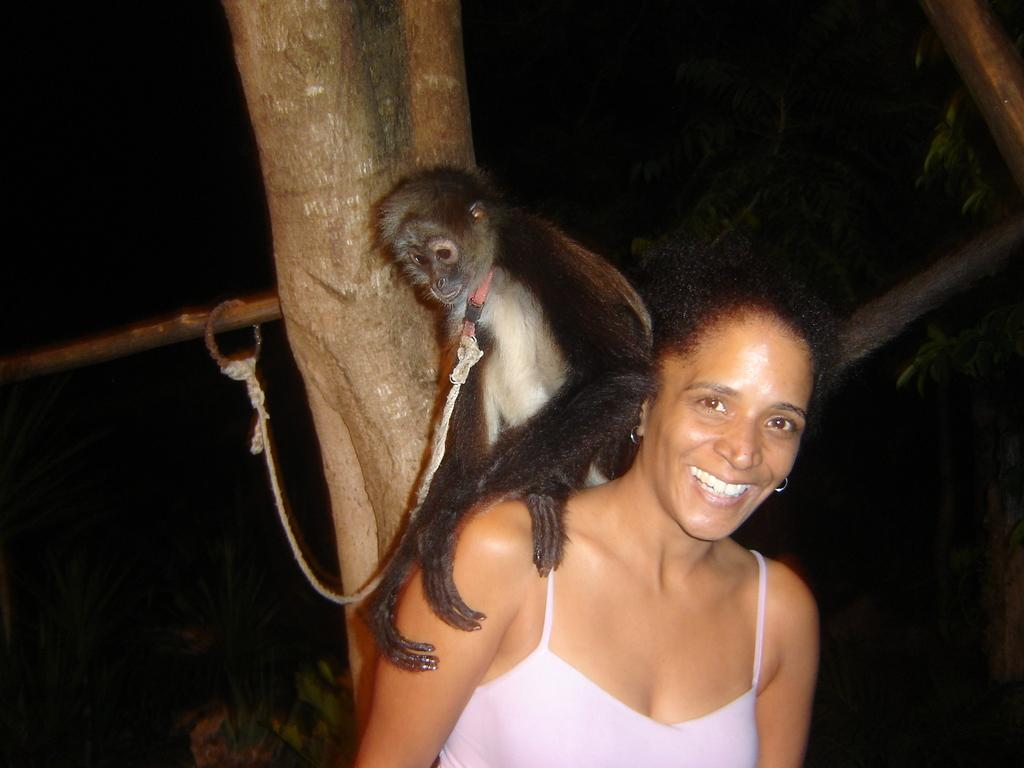Who is present in the image? There is a woman in the image. What is the woman doing in the image? The woman is smiling in the image. What other living creature is present in the image? There is a monkey in the image. Where is the monkey located in relation to the woman? The monkey is on the woman's shoulder in the image. What type of magic spell does the woman cast on the monkey in the image? There is no indication of magic or a spell being cast in the image; the woman is simply smiling with a monkey on her shoulder. 